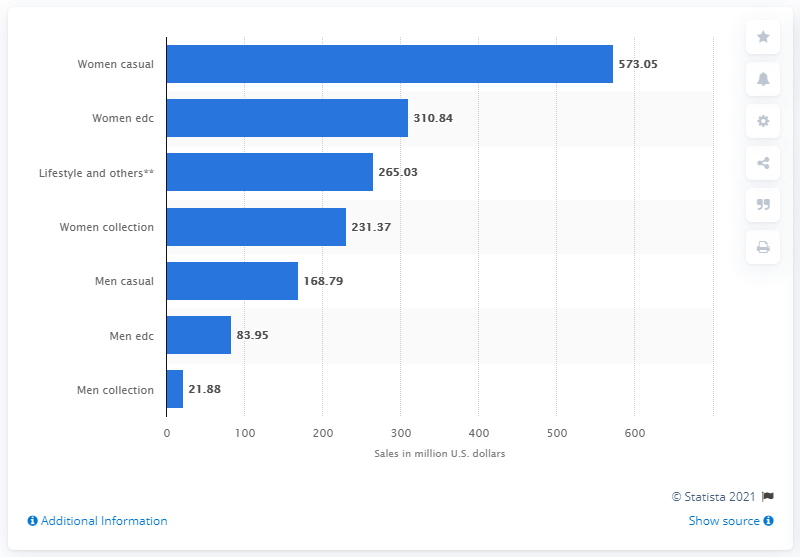Give some essential details in this illustration. In 2018/2019, the "women casual" segment of ESPRIT generated approximately 573.05 million U.S. dollars in revenue. 